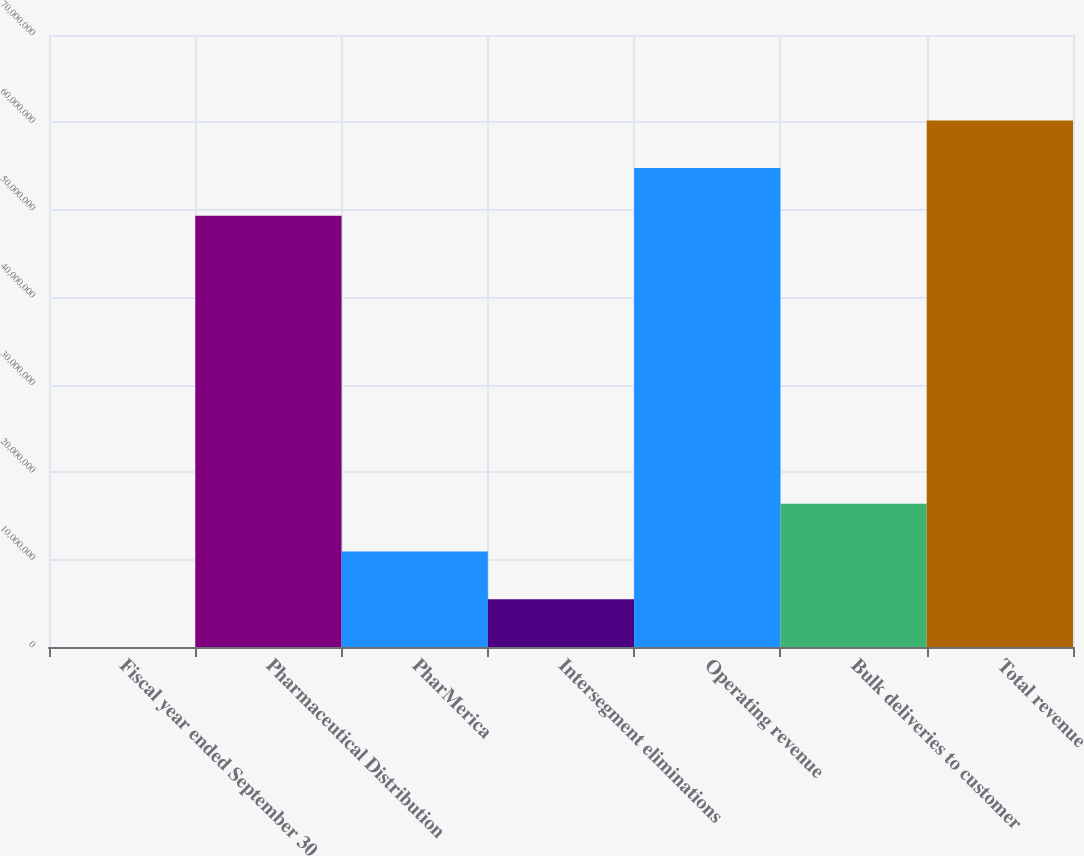Convert chart. <chart><loc_0><loc_0><loc_500><loc_500><bar_chart><fcel>Fiscal year ended September 30<fcel>Pharmaceutical Distribution<fcel>PharMerica<fcel>Intersegment eliminations<fcel>Operating revenue<fcel>Bulk deliveries to customer<fcel>Total revenue<nl><fcel>2005<fcel>4.93194e+07<fcel>1.09171e+07<fcel>5.45954e+06<fcel>5.47769e+07<fcel>1.63746e+07<fcel>6.02344e+07<nl></chart> 